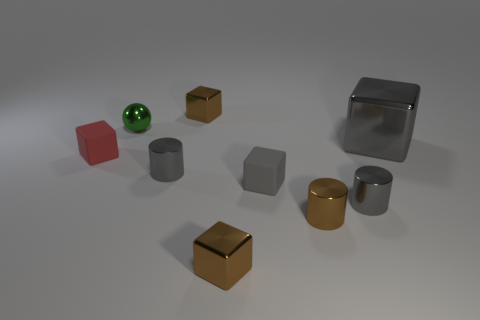Subtract all large gray blocks. How many blocks are left? 4 Subtract all red balls. How many gray cylinders are left? 2 Add 1 big purple matte spheres. How many objects exist? 10 Subtract all red blocks. How many blocks are left? 4 Subtract all gray blocks. Subtract all red spheres. How many blocks are left? 3 Add 2 tiny red shiny cubes. How many tiny red shiny cubes exist? 2 Subtract 0 yellow spheres. How many objects are left? 9 Subtract all spheres. How many objects are left? 8 Subtract all gray metal blocks. Subtract all red blocks. How many objects are left? 7 Add 7 small red rubber cubes. How many small red rubber cubes are left? 8 